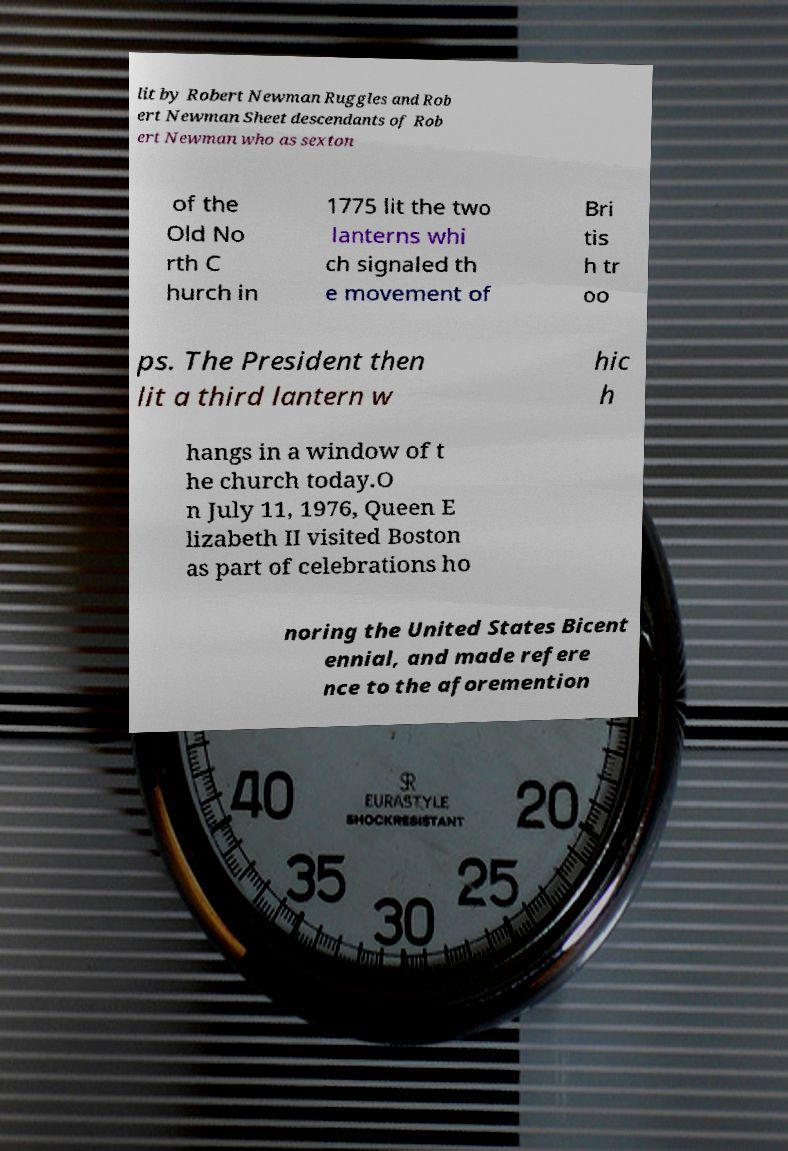Can you read and provide the text displayed in the image?This photo seems to have some interesting text. Can you extract and type it out for me? lit by Robert Newman Ruggles and Rob ert Newman Sheet descendants of Rob ert Newman who as sexton of the Old No rth C hurch in 1775 lit the two lanterns whi ch signaled th e movement of Bri tis h tr oo ps. The President then lit a third lantern w hic h hangs in a window of t he church today.O n July 11, 1976, Queen E lizabeth II visited Boston as part of celebrations ho noring the United States Bicent ennial, and made refere nce to the aforemention 